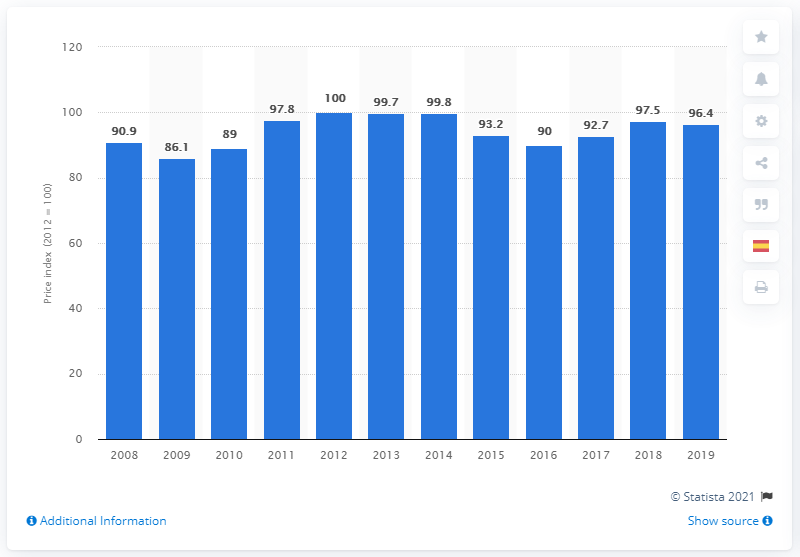Point out several critical features in this image. In 2019, the chemical price index in the United States was 96.4. In 2008, the price index for chemical products excluding pharmaceuticals in the United States was 90.9. 